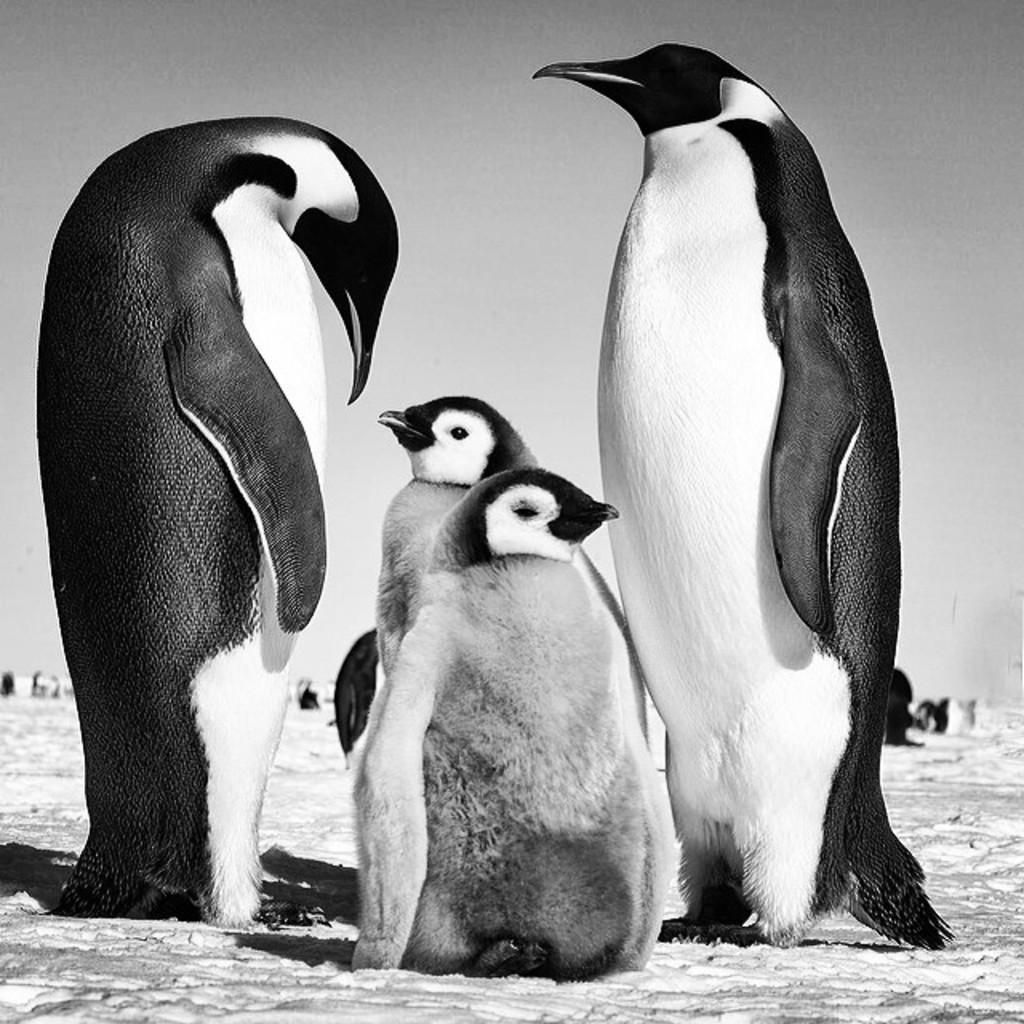Could you give a brief overview of what you see in this image? In this picture there are two big penguin and two small, standing on the snow ground. 